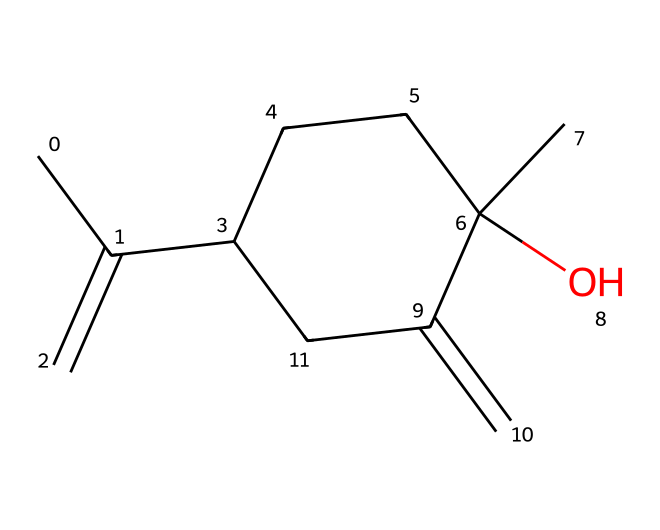How many carbon atoms are in this structure? By analyzing the SMILES representation, I can count the number of carbon (C) atoms. The SMILES starts with "CC", indicating at least two carbons. Continuing through the structure, I find a total of 10 carbon atoms.
Answer: 10 What functional group is present in this molecule? The structure shows an oxygen atom (O) bonded to a carbon atom, which suggests the presence of a hydroxyl (-OH) functional group. This is confirmed as the structure contains OH.
Answer: hydroxyl How many double bonds are present in this chemical structure? Examining the SMILES representation, I see two instances of "C=C" indicating double bonds between carbon atoms. Therefore, I can conclude there are two double bonds.
Answer: 2 What is the primary use of this chemical in children's relaxation exercises? This compound is well-known as lavender essential oil, which is commonly used for its calming and soothing properties in relaxation exercises for children.
Answer: relaxation What can you conclude about the polarity of this compound based on its structure? The presence of the hydroxyl group suggests that this compound is polar because the -OH group can form hydrogen bonds, making it more soluble in water relative to non-polar substances. Thus, I can conclude the compound is polar.
Answer: polar 